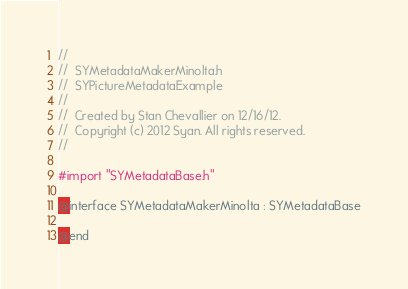Convert code to text. <code><loc_0><loc_0><loc_500><loc_500><_C_>//
//  SYMetadataMakerMinolta.h
//  SYPictureMetadataExample
//
//  Created by Stan Chevallier on 12/16/12.
//  Copyright (c) 2012 Syan. All rights reserved.
//

#import "SYMetadataBase.h"

@interface SYMetadataMakerMinolta : SYMetadataBase

@end
</code> 